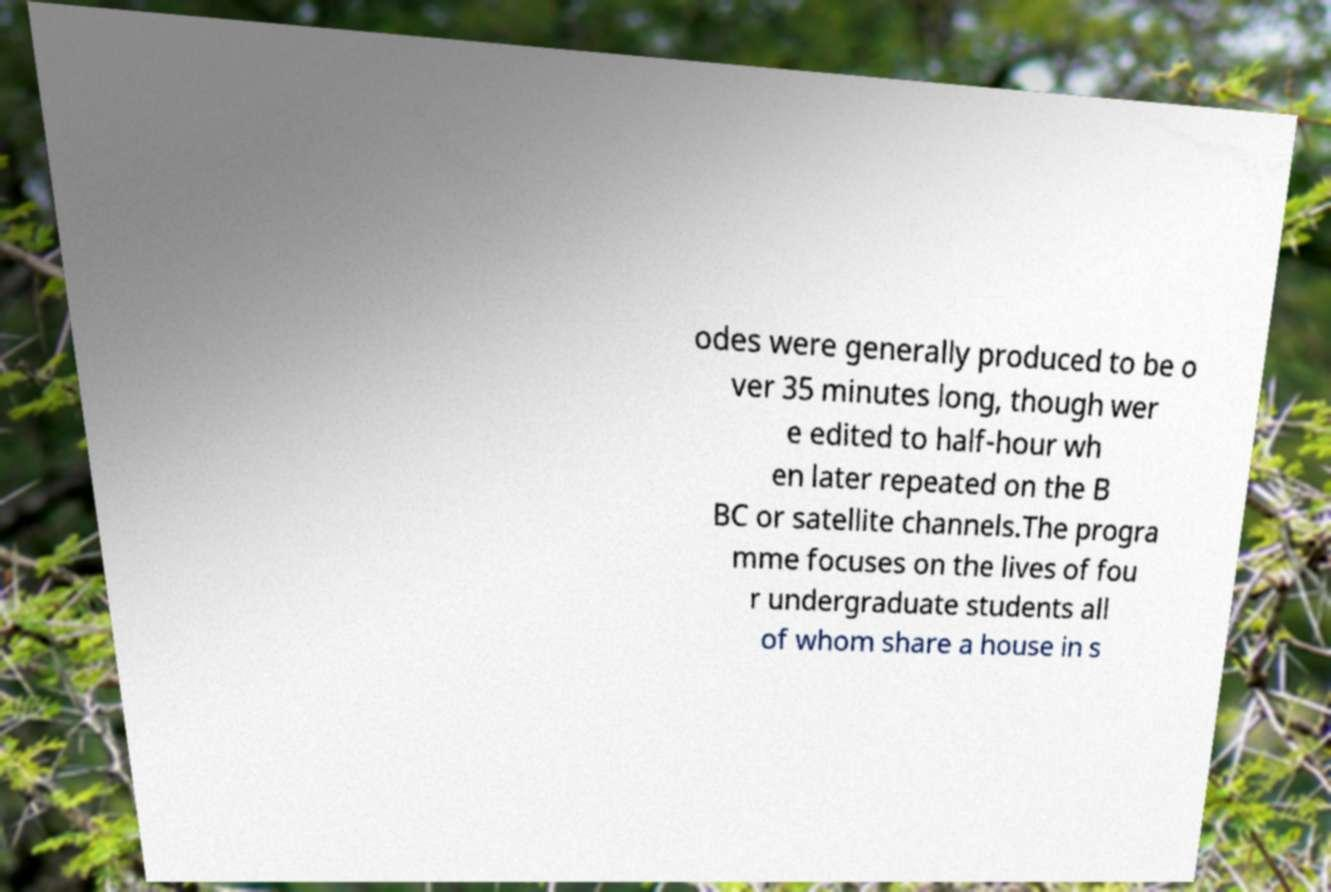Can you accurately transcribe the text from the provided image for me? odes were generally produced to be o ver 35 minutes long, though wer e edited to half-hour wh en later repeated on the B BC or satellite channels.The progra mme focuses on the lives of fou r undergraduate students all of whom share a house in s 